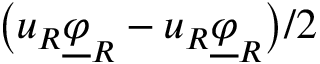<formula> <loc_0><loc_0><loc_500><loc_500>\left ( u _ { R } \underline { \varphi } _ { R } - u _ { R } \underline { \varphi } _ { R } \right ) / 2</formula> 